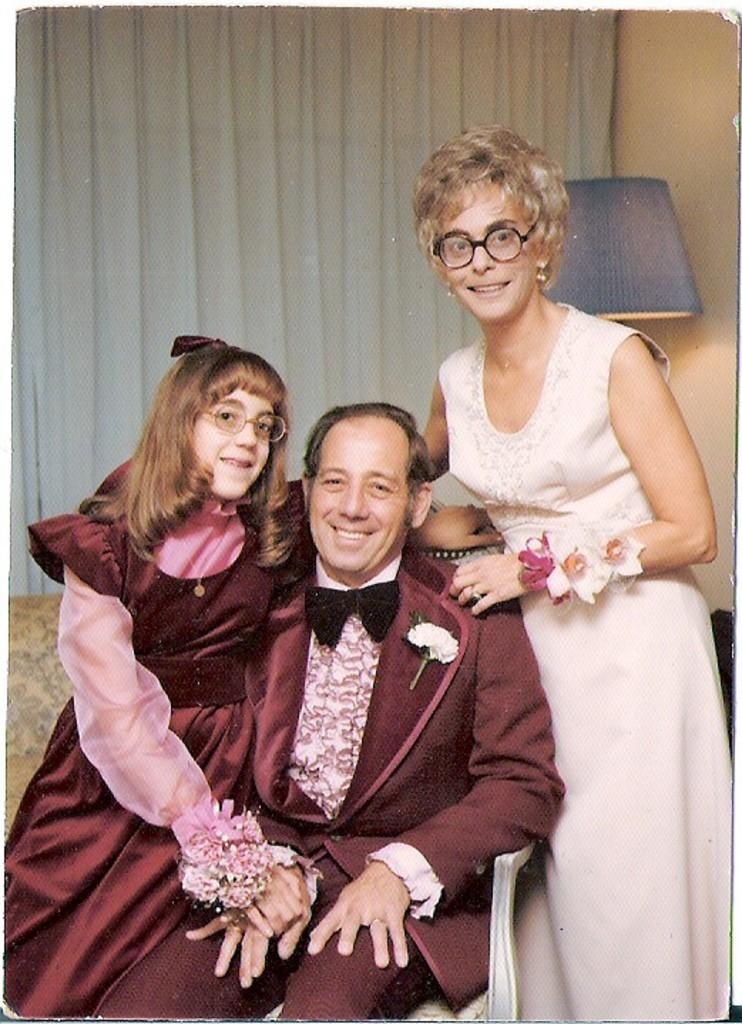How many people are in the image? There are three persons in the image. What can be seen in the background of the image? There is a curtain in the background of the image. What object provides light in the image? There is a lamp in the image. What is on the right side of the image? There is a wall on the right side of the image. Can you see any animals from the zoo in the image? There are no animals from the zoo present in the image. What type of store is depicted in the image? There is no store depicted in the image. 